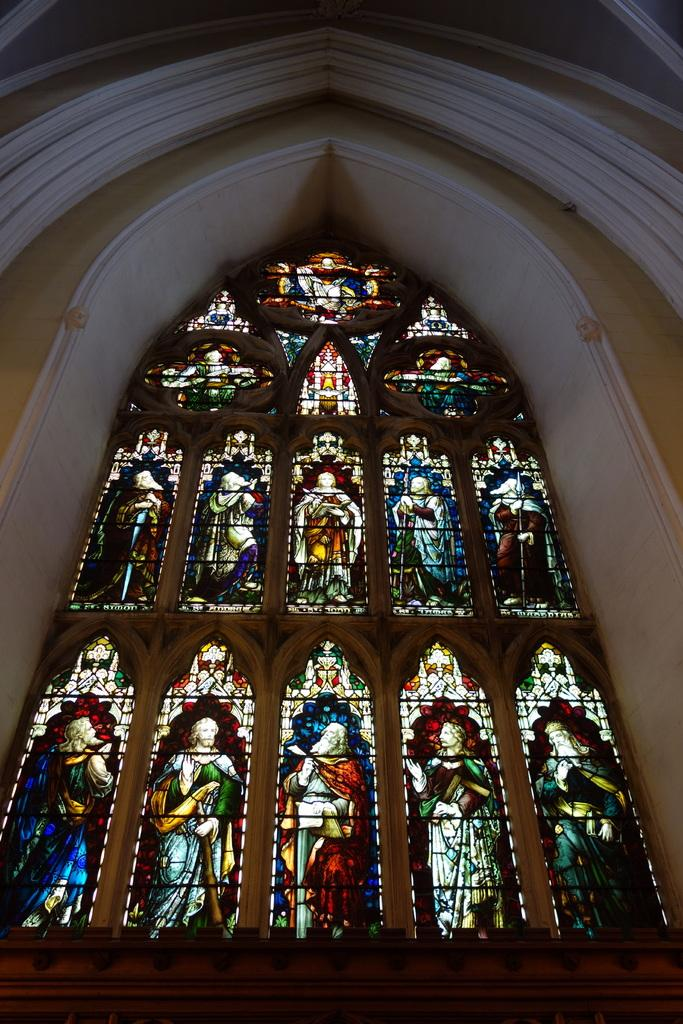What is depicted on the glass in the image? There is a painting of people on glass in the image. What else can be seen in the image besides the glass painting? There is a wall visible in the image. How many geese are present in the image? There are no geese present in the image. What type of mineral can be seen in the image? There is no mineral visible in the image. 